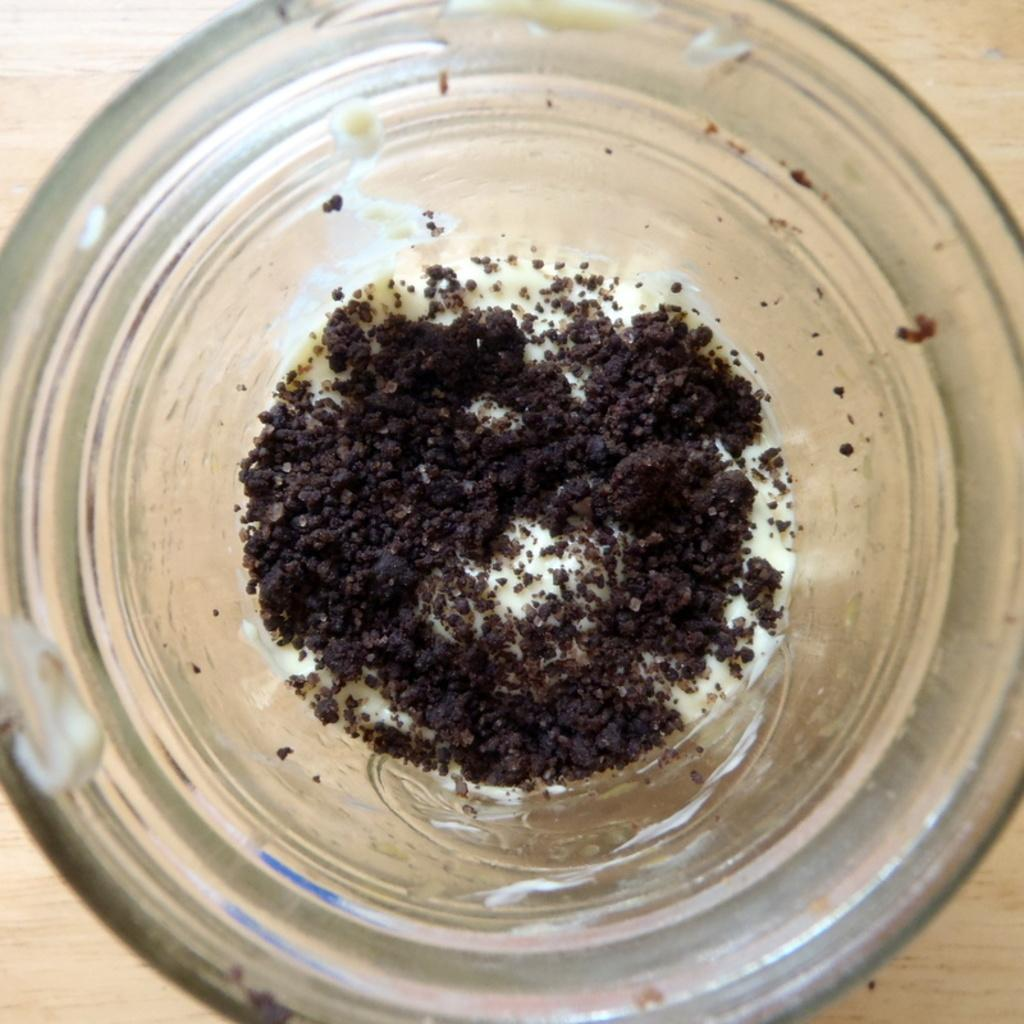What type of container is holding the food item in the image? There is a food item in a glass jar in the image. Can you describe the setting in which the food item is located? There is a table in the background of the image. What type of glue is being used to hold the queen's crown in the image? There is no queen or crown present in the image, and therefore no glue is being used. 